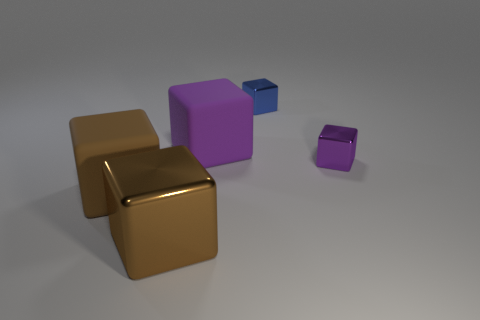Subtract all brown blocks. How many were subtracted if there are1brown blocks left? 1 Subtract all gray cubes. Subtract all green balls. How many cubes are left? 5 Add 2 small cyan rubber spheres. How many objects exist? 7 Add 5 large brown rubber objects. How many large brown rubber objects are left? 6 Add 1 big green matte balls. How many big green matte balls exist? 1 Subtract 0 brown cylinders. How many objects are left? 5 Subtract all blue cylinders. Subtract all small purple cubes. How many objects are left? 4 